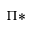<formula> <loc_0><loc_0><loc_500><loc_500>\Pi *</formula> 